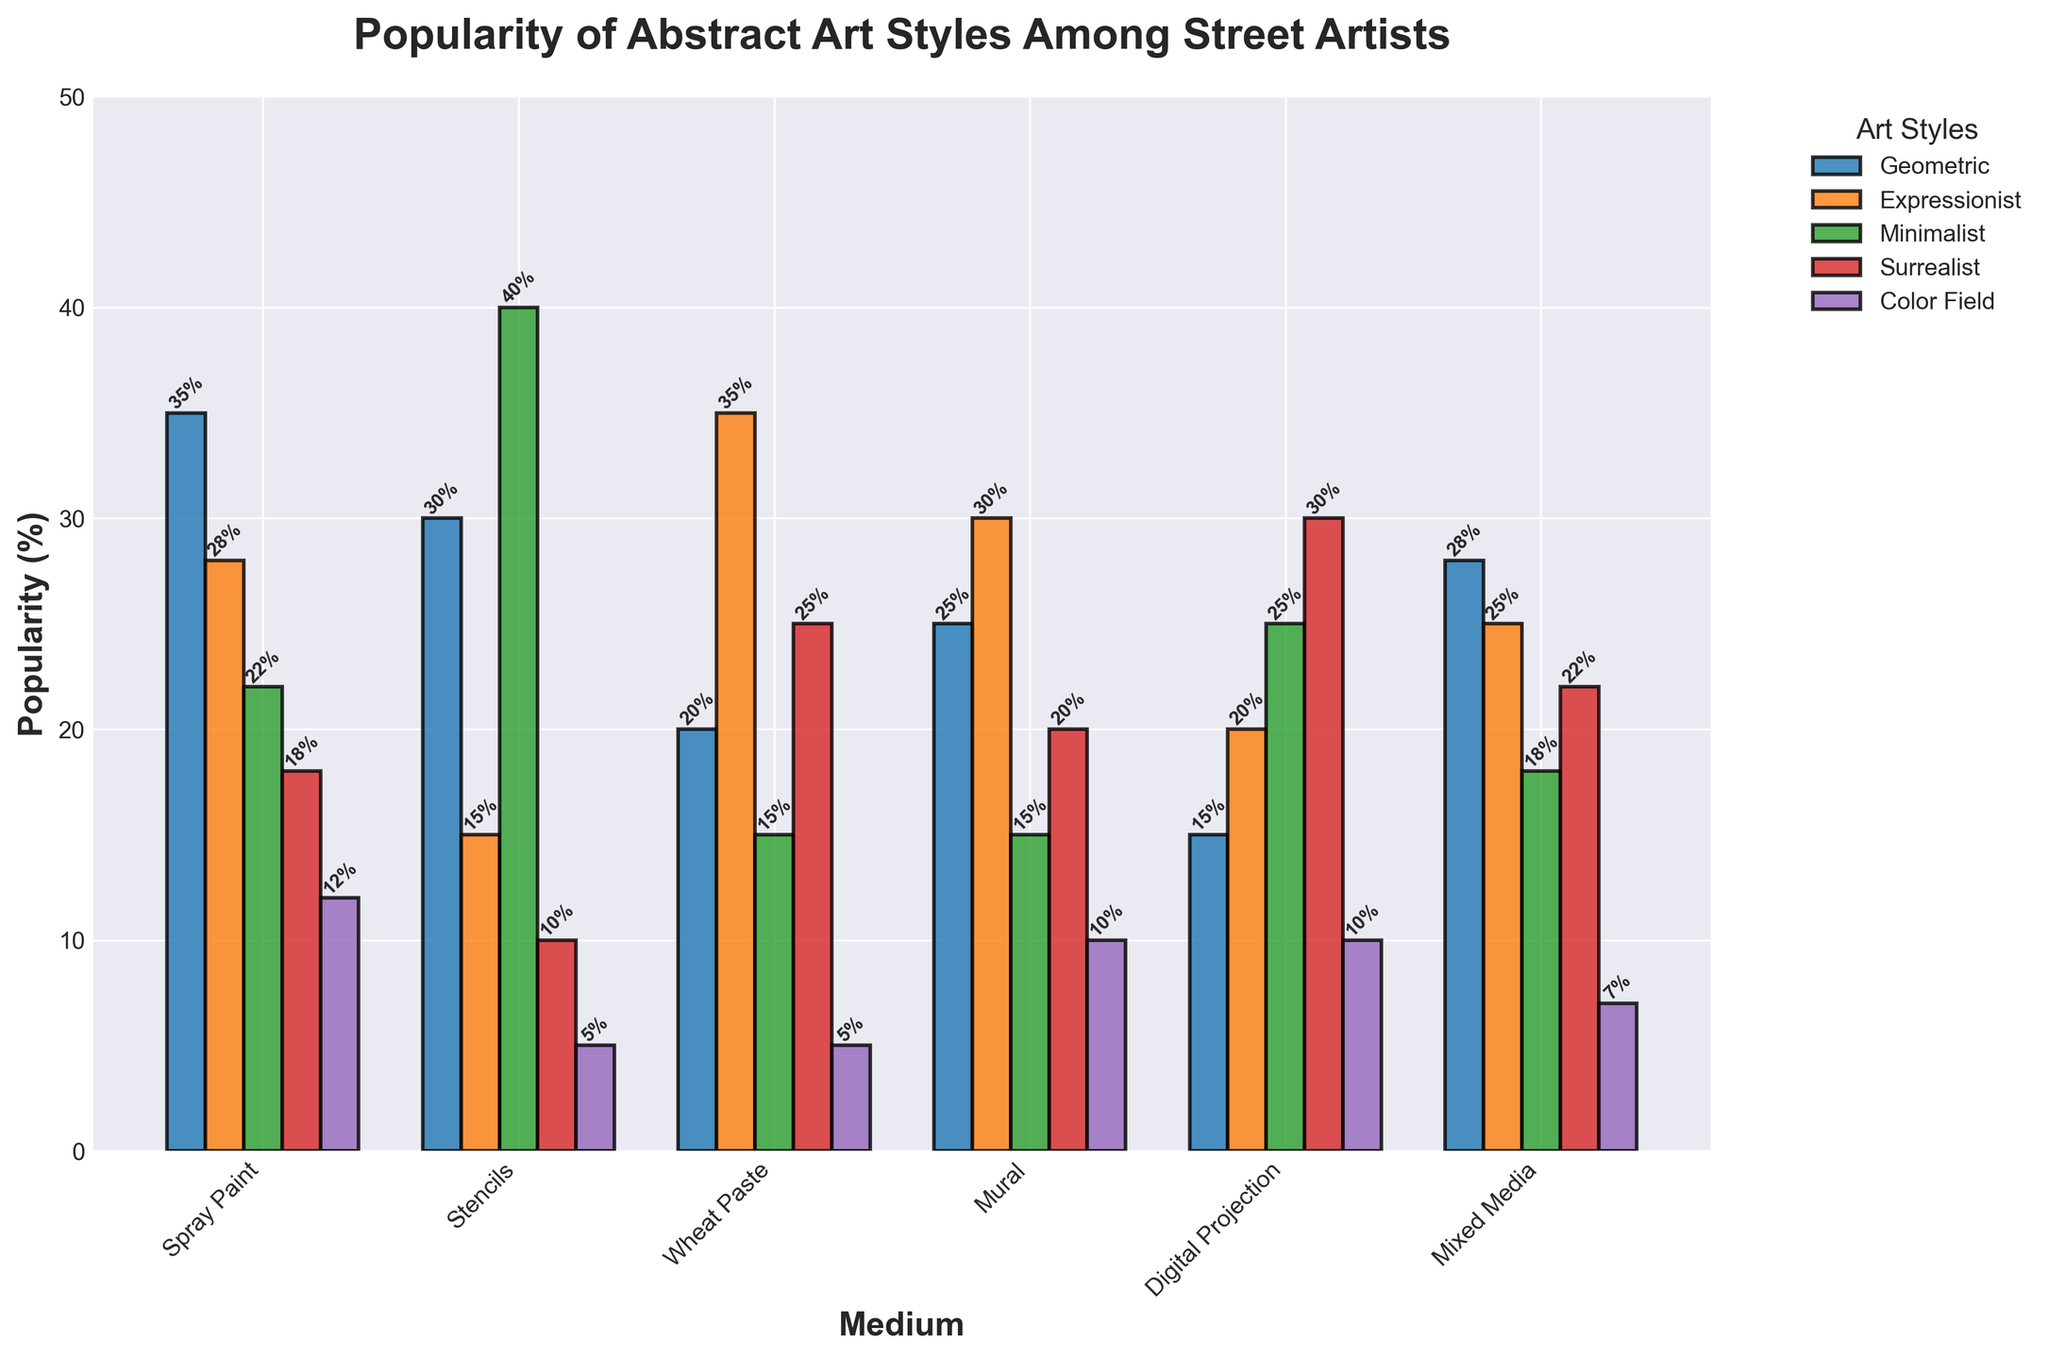What's the most popular abstract art style when using Spray Paint? Identify the bar with the highest value in the Spray Paint category and check its label. Geometric has the highest bar at 35%.
Answer: Geometric Which medium has the highest popularity for Expressionist art? Compare the heights of the bars for Expressionist in each medium and find the highest one. Wheat Paste has the highest bar at 35%.
Answer: Wheat Paste What is the total popularity percentage of Minimalist art across all mediums? Sum the values of Minimalist for each medium: 22 + 40 + 15 + 15 + 25 + 18 = 135%.
Answer: 135% How does the popularity of Surrealist art in Digital Projection compare to its popularity in Spray Paint? Compare the bar heights for Surrealist in Digital Projection (30%) and Spray Paint (18%). Surrealist is more popular in Digital Projection by 12%.
Answer: 12% higher in Digital Projection If you sum the popularity of Color Field style across Mixed Media and Mural, what's the percentage? Add the values for Color Field in both Mixed Media (7%) and Mural (10%): 7 + 10 = 17%.
Answer: 17% Which art style has the most universally even distribution among all mediums? Check which art style has bars of roughly equal heights across all mediums. Mixed Media comes closest for Expressionist. Check similarly sized bars for Expressionist in all mediums.
Answer: Expressionist For the Geometric style, by how much is its popularity in Stencils higher than in Digital Projection? Subtract the bar value of Geometric for Digital Projection (15%) from that for Stencils (30%): 30 - 15 = 15%.
Answer: 15% higher What is the average popularity percentage of Color Field art across all mediums? Divide the total popularity percentage for Color Field art by the number of mediums. (12 + 5 + 5 + 10 + 10 + 7) = 49%. 49 / 6 = 8.17%.
Answer: 8.17% Between Expressionist and Surrealist styles, which one has a higher total popularity percentage across all mediums? First, sum the percentages for Expressionist and Surrealist across all mediums. Expressionist: 28 + 15 + 35 + 30 + 20 + 25 = 153%. Surrealist: 18 + 10 + 25 + 20 + 30 + 22 = 125%. Compare the sums.
Answer: Expressionist (153%) What is the least popular abstract art style for Wheat Paste? Find the bar with the smallest height in the Wheat Paste category. Color Field has the smallest bar at 5%.
Answer: Color Field 